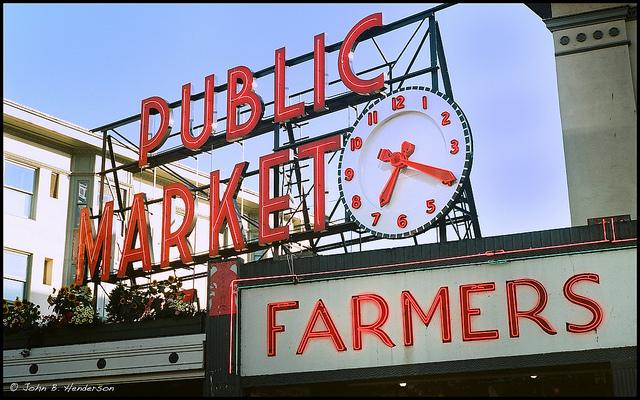Is the name of a group of people who grow vegetables visible in the picture?
Be succinct. Yes. What time is it in the photo?
Concise answer only. 7:20. What color are the letters?
Short answer required. Red. 